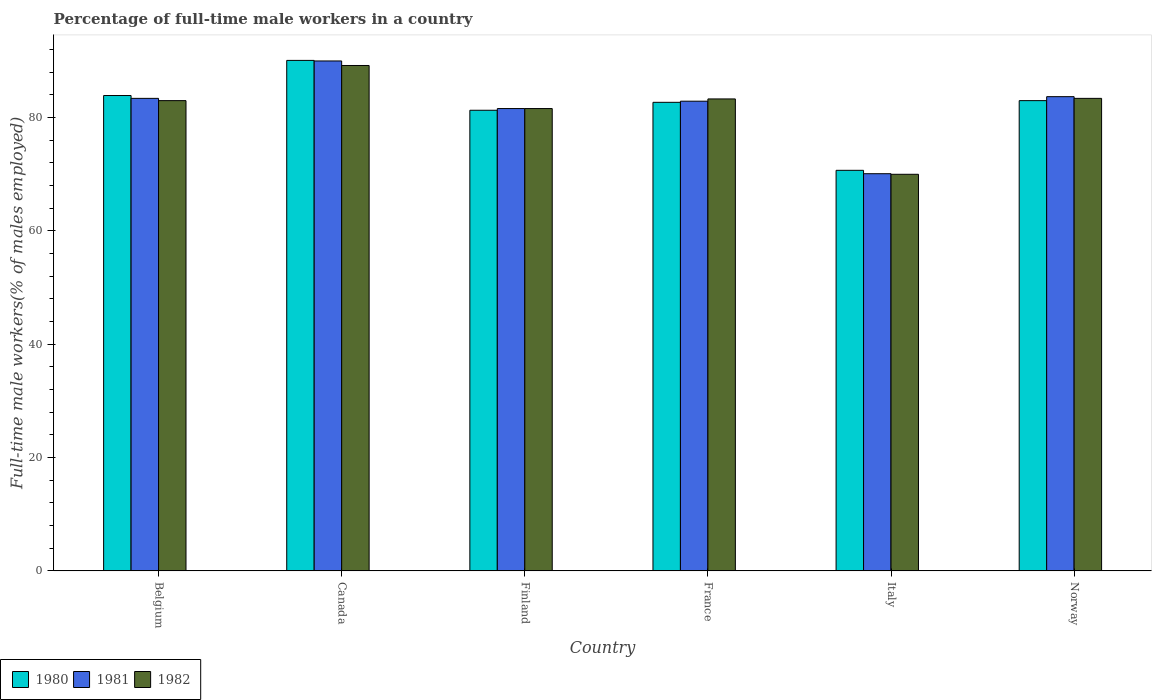How many different coloured bars are there?
Provide a succinct answer. 3. How many groups of bars are there?
Make the answer very short. 6. Are the number of bars per tick equal to the number of legend labels?
Offer a very short reply. Yes. Are the number of bars on each tick of the X-axis equal?
Keep it short and to the point. Yes. How many bars are there on the 5th tick from the left?
Offer a very short reply. 3. What is the label of the 5th group of bars from the left?
Provide a short and direct response. Italy. In how many cases, is the number of bars for a given country not equal to the number of legend labels?
Offer a very short reply. 0. What is the percentage of full-time male workers in 1981 in Finland?
Make the answer very short. 81.6. Across all countries, what is the maximum percentage of full-time male workers in 1982?
Offer a terse response. 89.2. Across all countries, what is the minimum percentage of full-time male workers in 1980?
Offer a very short reply. 70.7. In which country was the percentage of full-time male workers in 1982 maximum?
Provide a short and direct response. Canada. What is the total percentage of full-time male workers in 1980 in the graph?
Offer a very short reply. 491.7. What is the difference between the percentage of full-time male workers in 1980 in Canada and that in Norway?
Provide a short and direct response. 7.1. What is the difference between the percentage of full-time male workers in 1982 in Belgium and the percentage of full-time male workers in 1981 in Finland?
Give a very brief answer. 1.4. What is the average percentage of full-time male workers in 1980 per country?
Ensure brevity in your answer.  81.95. What is the difference between the percentage of full-time male workers of/in 1982 and percentage of full-time male workers of/in 1980 in Finland?
Ensure brevity in your answer.  0.3. What is the ratio of the percentage of full-time male workers in 1980 in Finland to that in Italy?
Offer a terse response. 1.15. Is the difference between the percentage of full-time male workers in 1982 in Belgium and Italy greater than the difference between the percentage of full-time male workers in 1980 in Belgium and Italy?
Keep it short and to the point. No. What is the difference between the highest and the second highest percentage of full-time male workers in 1982?
Provide a succinct answer. 5.9. What is the difference between the highest and the lowest percentage of full-time male workers in 1980?
Provide a succinct answer. 19.4. In how many countries, is the percentage of full-time male workers in 1982 greater than the average percentage of full-time male workers in 1982 taken over all countries?
Keep it short and to the point. 4. What does the 3rd bar from the right in Norway represents?
Your answer should be compact. 1980. How many countries are there in the graph?
Give a very brief answer. 6. Does the graph contain grids?
Your response must be concise. No. How many legend labels are there?
Offer a terse response. 3. How are the legend labels stacked?
Offer a terse response. Horizontal. What is the title of the graph?
Ensure brevity in your answer.  Percentage of full-time male workers in a country. Does "2000" appear as one of the legend labels in the graph?
Give a very brief answer. No. What is the label or title of the Y-axis?
Provide a succinct answer. Full-time male workers(% of males employed). What is the Full-time male workers(% of males employed) in 1980 in Belgium?
Provide a short and direct response. 83.9. What is the Full-time male workers(% of males employed) in 1981 in Belgium?
Make the answer very short. 83.4. What is the Full-time male workers(% of males employed) in 1982 in Belgium?
Keep it short and to the point. 83. What is the Full-time male workers(% of males employed) in 1980 in Canada?
Provide a short and direct response. 90.1. What is the Full-time male workers(% of males employed) of 1981 in Canada?
Offer a terse response. 90. What is the Full-time male workers(% of males employed) in 1982 in Canada?
Give a very brief answer. 89.2. What is the Full-time male workers(% of males employed) of 1980 in Finland?
Keep it short and to the point. 81.3. What is the Full-time male workers(% of males employed) in 1981 in Finland?
Offer a terse response. 81.6. What is the Full-time male workers(% of males employed) of 1982 in Finland?
Make the answer very short. 81.6. What is the Full-time male workers(% of males employed) in 1980 in France?
Your answer should be very brief. 82.7. What is the Full-time male workers(% of males employed) of 1981 in France?
Make the answer very short. 82.9. What is the Full-time male workers(% of males employed) in 1982 in France?
Your response must be concise. 83.3. What is the Full-time male workers(% of males employed) in 1980 in Italy?
Your answer should be very brief. 70.7. What is the Full-time male workers(% of males employed) in 1981 in Italy?
Give a very brief answer. 70.1. What is the Full-time male workers(% of males employed) of 1980 in Norway?
Ensure brevity in your answer.  83. What is the Full-time male workers(% of males employed) in 1981 in Norway?
Offer a very short reply. 83.7. What is the Full-time male workers(% of males employed) in 1982 in Norway?
Ensure brevity in your answer.  83.4. Across all countries, what is the maximum Full-time male workers(% of males employed) in 1980?
Offer a terse response. 90.1. Across all countries, what is the maximum Full-time male workers(% of males employed) of 1982?
Your answer should be very brief. 89.2. Across all countries, what is the minimum Full-time male workers(% of males employed) in 1980?
Offer a very short reply. 70.7. Across all countries, what is the minimum Full-time male workers(% of males employed) of 1981?
Provide a short and direct response. 70.1. What is the total Full-time male workers(% of males employed) in 1980 in the graph?
Give a very brief answer. 491.7. What is the total Full-time male workers(% of males employed) of 1981 in the graph?
Ensure brevity in your answer.  491.7. What is the total Full-time male workers(% of males employed) in 1982 in the graph?
Make the answer very short. 490.5. What is the difference between the Full-time male workers(% of males employed) in 1980 in Belgium and that in Finland?
Offer a terse response. 2.6. What is the difference between the Full-time male workers(% of males employed) of 1981 in Belgium and that in Finland?
Provide a succinct answer. 1.8. What is the difference between the Full-time male workers(% of males employed) in 1980 in Belgium and that in Italy?
Give a very brief answer. 13.2. What is the difference between the Full-time male workers(% of males employed) of 1982 in Belgium and that in Italy?
Give a very brief answer. 13. What is the difference between the Full-time male workers(% of males employed) of 1980 in Belgium and that in Norway?
Your response must be concise. 0.9. What is the difference between the Full-time male workers(% of males employed) of 1982 in Belgium and that in Norway?
Keep it short and to the point. -0.4. What is the difference between the Full-time male workers(% of males employed) in 1982 in Canada and that in Finland?
Offer a terse response. 7.6. What is the difference between the Full-time male workers(% of males employed) in 1980 in Canada and that in France?
Offer a very short reply. 7.4. What is the difference between the Full-time male workers(% of males employed) in 1982 in Canada and that in France?
Offer a terse response. 5.9. What is the difference between the Full-time male workers(% of males employed) of 1981 in Canada and that in Italy?
Offer a terse response. 19.9. What is the difference between the Full-time male workers(% of males employed) in 1982 in Canada and that in Italy?
Provide a short and direct response. 19.2. What is the difference between the Full-time male workers(% of males employed) in 1981 in Canada and that in Norway?
Your answer should be compact. 6.3. What is the difference between the Full-time male workers(% of males employed) in 1982 in Canada and that in Norway?
Provide a succinct answer. 5.8. What is the difference between the Full-time male workers(% of males employed) in 1980 in Finland and that in Italy?
Your answer should be compact. 10.6. What is the difference between the Full-time male workers(% of males employed) of 1981 in Finland and that in Italy?
Your answer should be compact. 11.5. What is the difference between the Full-time male workers(% of males employed) in 1980 in Finland and that in Norway?
Your response must be concise. -1.7. What is the difference between the Full-time male workers(% of males employed) in 1982 in Finland and that in Norway?
Your answer should be very brief. -1.8. What is the difference between the Full-time male workers(% of males employed) of 1980 in France and that in Italy?
Offer a very short reply. 12. What is the difference between the Full-time male workers(% of males employed) of 1981 in France and that in Italy?
Make the answer very short. 12.8. What is the difference between the Full-time male workers(% of males employed) of 1982 in France and that in Norway?
Provide a succinct answer. -0.1. What is the difference between the Full-time male workers(% of males employed) in 1980 in Belgium and the Full-time male workers(% of males employed) in 1981 in Canada?
Your answer should be very brief. -6.1. What is the difference between the Full-time male workers(% of males employed) of 1981 in Belgium and the Full-time male workers(% of males employed) of 1982 in Finland?
Give a very brief answer. 1.8. What is the difference between the Full-time male workers(% of males employed) of 1980 in Belgium and the Full-time male workers(% of males employed) of 1982 in France?
Offer a terse response. 0.6. What is the difference between the Full-time male workers(% of males employed) of 1980 in Belgium and the Full-time male workers(% of males employed) of 1981 in Italy?
Your answer should be compact. 13.8. What is the difference between the Full-time male workers(% of males employed) in 1980 in Belgium and the Full-time male workers(% of males employed) in 1982 in Italy?
Give a very brief answer. 13.9. What is the difference between the Full-time male workers(% of males employed) in 1981 in Belgium and the Full-time male workers(% of males employed) in 1982 in Norway?
Your answer should be compact. 0. What is the difference between the Full-time male workers(% of males employed) in 1980 in Canada and the Full-time male workers(% of males employed) in 1982 in Finland?
Keep it short and to the point. 8.5. What is the difference between the Full-time male workers(% of males employed) of 1981 in Canada and the Full-time male workers(% of males employed) of 1982 in Finland?
Offer a terse response. 8.4. What is the difference between the Full-time male workers(% of males employed) of 1980 in Canada and the Full-time male workers(% of males employed) of 1981 in France?
Give a very brief answer. 7.2. What is the difference between the Full-time male workers(% of males employed) of 1980 in Canada and the Full-time male workers(% of males employed) of 1982 in Italy?
Offer a terse response. 20.1. What is the difference between the Full-time male workers(% of males employed) of 1981 in Canada and the Full-time male workers(% of males employed) of 1982 in Italy?
Offer a very short reply. 20. What is the difference between the Full-time male workers(% of males employed) in 1980 in Finland and the Full-time male workers(% of males employed) in 1981 in France?
Make the answer very short. -1.6. What is the difference between the Full-time male workers(% of males employed) of 1980 in Finland and the Full-time male workers(% of males employed) of 1981 in Norway?
Offer a very short reply. -2.4. What is the difference between the Full-time male workers(% of males employed) in 1980 in Finland and the Full-time male workers(% of males employed) in 1982 in Norway?
Keep it short and to the point. -2.1. What is the difference between the Full-time male workers(% of males employed) in 1981 in Finland and the Full-time male workers(% of males employed) in 1982 in Norway?
Your response must be concise. -1.8. What is the difference between the Full-time male workers(% of males employed) in 1980 in France and the Full-time male workers(% of males employed) in 1982 in Italy?
Make the answer very short. 12.7. What is the difference between the Full-time male workers(% of males employed) in 1981 in France and the Full-time male workers(% of males employed) in 1982 in Italy?
Your response must be concise. 12.9. What is the difference between the Full-time male workers(% of males employed) of 1980 in France and the Full-time male workers(% of males employed) of 1982 in Norway?
Make the answer very short. -0.7. What is the difference between the Full-time male workers(% of males employed) of 1981 in France and the Full-time male workers(% of males employed) of 1982 in Norway?
Make the answer very short. -0.5. What is the difference between the Full-time male workers(% of males employed) in 1980 in Italy and the Full-time male workers(% of males employed) in 1981 in Norway?
Provide a short and direct response. -13. What is the difference between the Full-time male workers(% of males employed) of 1981 in Italy and the Full-time male workers(% of males employed) of 1982 in Norway?
Give a very brief answer. -13.3. What is the average Full-time male workers(% of males employed) in 1980 per country?
Give a very brief answer. 81.95. What is the average Full-time male workers(% of males employed) of 1981 per country?
Your answer should be compact. 81.95. What is the average Full-time male workers(% of males employed) of 1982 per country?
Offer a terse response. 81.75. What is the difference between the Full-time male workers(% of males employed) of 1980 and Full-time male workers(% of males employed) of 1981 in Canada?
Your answer should be compact. 0.1. What is the difference between the Full-time male workers(% of males employed) in 1980 and Full-time male workers(% of males employed) in 1982 in Canada?
Provide a short and direct response. 0.9. What is the difference between the Full-time male workers(% of males employed) of 1981 and Full-time male workers(% of males employed) of 1982 in Canada?
Offer a terse response. 0.8. What is the difference between the Full-time male workers(% of males employed) of 1980 and Full-time male workers(% of males employed) of 1981 in Finland?
Give a very brief answer. -0.3. What is the difference between the Full-time male workers(% of males employed) of 1980 and Full-time male workers(% of males employed) of 1982 in Finland?
Provide a succinct answer. -0.3. What is the difference between the Full-time male workers(% of males employed) of 1980 and Full-time male workers(% of males employed) of 1981 in Italy?
Give a very brief answer. 0.6. What is the difference between the Full-time male workers(% of males employed) of 1980 and Full-time male workers(% of males employed) of 1982 in Italy?
Keep it short and to the point. 0.7. What is the difference between the Full-time male workers(% of males employed) in 1981 and Full-time male workers(% of males employed) in 1982 in Italy?
Ensure brevity in your answer.  0.1. What is the difference between the Full-time male workers(% of males employed) of 1980 and Full-time male workers(% of males employed) of 1982 in Norway?
Give a very brief answer. -0.4. What is the ratio of the Full-time male workers(% of males employed) of 1980 in Belgium to that in Canada?
Offer a terse response. 0.93. What is the ratio of the Full-time male workers(% of males employed) of 1981 in Belgium to that in Canada?
Keep it short and to the point. 0.93. What is the ratio of the Full-time male workers(% of males employed) in 1982 in Belgium to that in Canada?
Keep it short and to the point. 0.93. What is the ratio of the Full-time male workers(% of males employed) of 1980 in Belgium to that in Finland?
Your response must be concise. 1.03. What is the ratio of the Full-time male workers(% of males employed) in 1981 in Belgium to that in Finland?
Offer a terse response. 1.02. What is the ratio of the Full-time male workers(% of males employed) in 1982 in Belgium to that in Finland?
Provide a short and direct response. 1.02. What is the ratio of the Full-time male workers(% of males employed) of 1980 in Belgium to that in France?
Provide a short and direct response. 1.01. What is the ratio of the Full-time male workers(% of males employed) in 1982 in Belgium to that in France?
Provide a succinct answer. 1. What is the ratio of the Full-time male workers(% of males employed) in 1980 in Belgium to that in Italy?
Give a very brief answer. 1.19. What is the ratio of the Full-time male workers(% of males employed) of 1981 in Belgium to that in Italy?
Make the answer very short. 1.19. What is the ratio of the Full-time male workers(% of males employed) in 1982 in Belgium to that in Italy?
Ensure brevity in your answer.  1.19. What is the ratio of the Full-time male workers(% of males employed) in 1980 in Belgium to that in Norway?
Offer a very short reply. 1.01. What is the ratio of the Full-time male workers(% of males employed) of 1981 in Belgium to that in Norway?
Your answer should be compact. 1. What is the ratio of the Full-time male workers(% of males employed) of 1980 in Canada to that in Finland?
Your answer should be very brief. 1.11. What is the ratio of the Full-time male workers(% of males employed) in 1981 in Canada to that in Finland?
Provide a short and direct response. 1.1. What is the ratio of the Full-time male workers(% of males employed) of 1982 in Canada to that in Finland?
Your response must be concise. 1.09. What is the ratio of the Full-time male workers(% of males employed) of 1980 in Canada to that in France?
Your response must be concise. 1.09. What is the ratio of the Full-time male workers(% of males employed) of 1981 in Canada to that in France?
Provide a succinct answer. 1.09. What is the ratio of the Full-time male workers(% of males employed) of 1982 in Canada to that in France?
Your response must be concise. 1.07. What is the ratio of the Full-time male workers(% of males employed) in 1980 in Canada to that in Italy?
Keep it short and to the point. 1.27. What is the ratio of the Full-time male workers(% of males employed) in 1981 in Canada to that in Italy?
Your answer should be very brief. 1.28. What is the ratio of the Full-time male workers(% of males employed) in 1982 in Canada to that in Italy?
Keep it short and to the point. 1.27. What is the ratio of the Full-time male workers(% of males employed) of 1980 in Canada to that in Norway?
Keep it short and to the point. 1.09. What is the ratio of the Full-time male workers(% of males employed) in 1981 in Canada to that in Norway?
Ensure brevity in your answer.  1.08. What is the ratio of the Full-time male workers(% of males employed) in 1982 in Canada to that in Norway?
Provide a short and direct response. 1.07. What is the ratio of the Full-time male workers(% of males employed) of 1980 in Finland to that in France?
Ensure brevity in your answer.  0.98. What is the ratio of the Full-time male workers(% of males employed) of 1981 in Finland to that in France?
Provide a succinct answer. 0.98. What is the ratio of the Full-time male workers(% of males employed) of 1982 in Finland to that in France?
Your response must be concise. 0.98. What is the ratio of the Full-time male workers(% of males employed) in 1980 in Finland to that in Italy?
Your answer should be compact. 1.15. What is the ratio of the Full-time male workers(% of males employed) of 1981 in Finland to that in Italy?
Offer a very short reply. 1.16. What is the ratio of the Full-time male workers(% of males employed) of 1982 in Finland to that in Italy?
Provide a short and direct response. 1.17. What is the ratio of the Full-time male workers(% of males employed) of 1980 in Finland to that in Norway?
Ensure brevity in your answer.  0.98. What is the ratio of the Full-time male workers(% of males employed) in 1981 in Finland to that in Norway?
Give a very brief answer. 0.97. What is the ratio of the Full-time male workers(% of males employed) in 1982 in Finland to that in Norway?
Your answer should be compact. 0.98. What is the ratio of the Full-time male workers(% of males employed) in 1980 in France to that in Italy?
Provide a short and direct response. 1.17. What is the ratio of the Full-time male workers(% of males employed) in 1981 in France to that in Italy?
Your answer should be compact. 1.18. What is the ratio of the Full-time male workers(% of males employed) of 1982 in France to that in Italy?
Ensure brevity in your answer.  1.19. What is the ratio of the Full-time male workers(% of males employed) of 1980 in France to that in Norway?
Your response must be concise. 1. What is the ratio of the Full-time male workers(% of males employed) in 1980 in Italy to that in Norway?
Provide a short and direct response. 0.85. What is the ratio of the Full-time male workers(% of males employed) of 1981 in Italy to that in Norway?
Keep it short and to the point. 0.84. What is the ratio of the Full-time male workers(% of males employed) of 1982 in Italy to that in Norway?
Make the answer very short. 0.84. What is the difference between the highest and the second highest Full-time male workers(% of males employed) of 1981?
Offer a terse response. 6.3. What is the difference between the highest and the lowest Full-time male workers(% of males employed) in 1981?
Your answer should be very brief. 19.9. What is the difference between the highest and the lowest Full-time male workers(% of males employed) in 1982?
Offer a terse response. 19.2. 